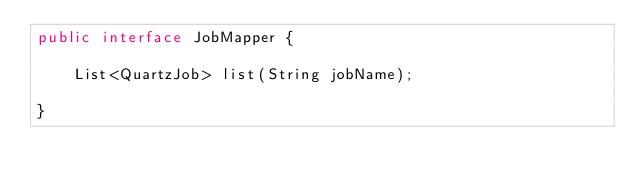<code> <loc_0><loc_0><loc_500><loc_500><_Java_>public interface JobMapper {

    List<QuartzJob> list(String jobName);

}
</code> 